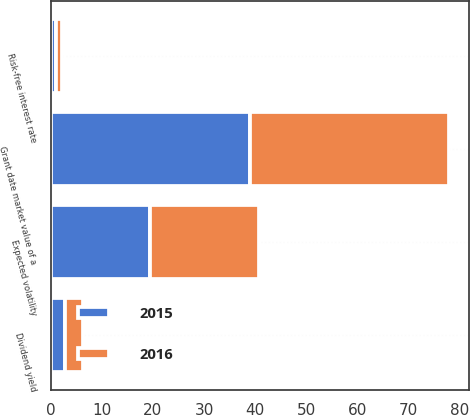Convert chart to OTSL. <chart><loc_0><loc_0><loc_500><loc_500><stacked_bar_chart><ecel><fcel>Grant date market value of a<fcel>Risk-free interest rate<fcel>Dividend yield<fcel>Expected volatility<nl><fcel>2016<fcel>38.73<fcel>1.15<fcel>3.41<fcel>21.24<nl><fcel>2015<fcel>39.05<fcel>1.04<fcel>2.87<fcel>19.48<nl></chart> 